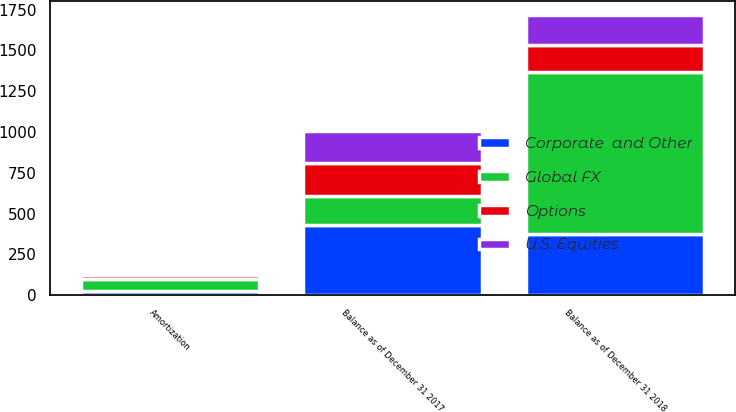<chart> <loc_0><loc_0><loc_500><loc_500><stacked_bar_chart><ecel><fcel>Amortization<fcel>Balance as of December 31 2017<fcel>Balance as of December 31 2018<nl><fcel>U.S. Equities<fcel>15.1<fcel>198.7<fcel>181.9<nl><fcel>Global FX<fcel>74.3<fcel>181.9<fcel>990.3<nl><fcel>Corporate  and Other<fcel>23.8<fcel>427<fcel>376.9<nl><fcel>Options<fcel>28.5<fcel>199.6<fcel>166.9<nl></chart> 